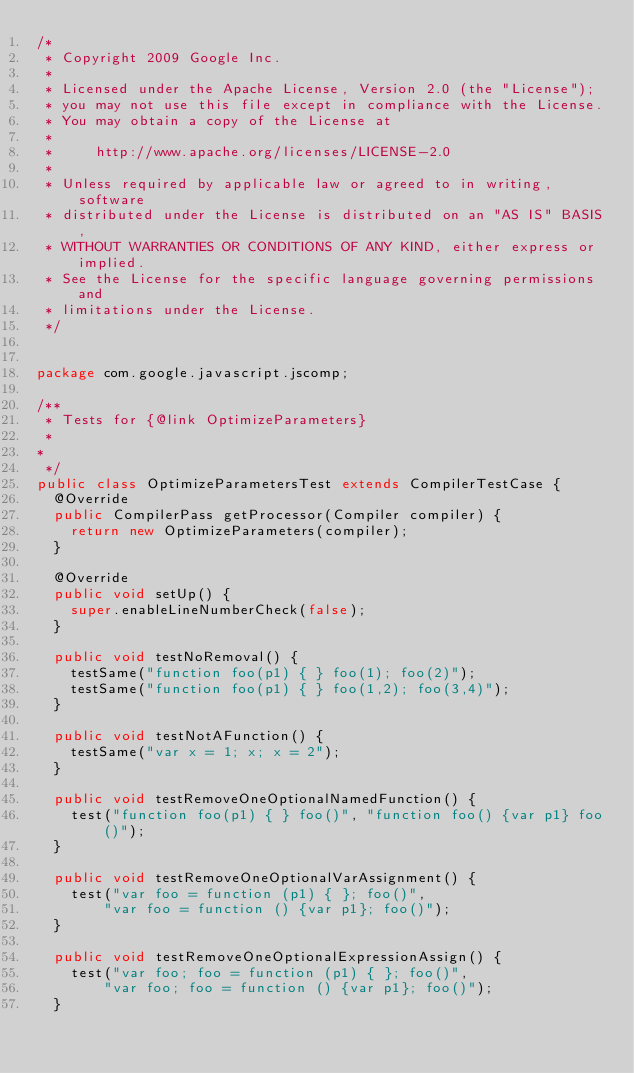Convert code to text. <code><loc_0><loc_0><loc_500><loc_500><_Java_>/*
 * Copyright 2009 Google Inc.
 *
 * Licensed under the Apache License, Version 2.0 (the "License");
 * you may not use this file except in compliance with the License.
 * You may obtain a copy of the License at
 *
 *     http://www.apache.org/licenses/LICENSE-2.0
 *
 * Unless required by applicable law or agreed to in writing, software
 * distributed under the License is distributed on an "AS IS" BASIS,
 * WITHOUT WARRANTIES OR CONDITIONS OF ANY KIND, either express or implied.
 * See the License for the specific language governing permissions and
 * limitations under the License.
 */


package com.google.javascript.jscomp;

/**
 * Tests for {@link OptimizeParameters}
 *
*
 */
public class OptimizeParametersTest extends CompilerTestCase {
  @Override
  public CompilerPass getProcessor(Compiler compiler) {
    return new OptimizeParameters(compiler);
  }

  @Override
  public void setUp() {
    super.enableLineNumberCheck(false);
  }

  public void testNoRemoval() {
    testSame("function foo(p1) { } foo(1); foo(2)");
    testSame("function foo(p1) { } foo(1,2); foo(3,4)");
  }

  public void testNotAFunction() {
    testSame("var x = 1; x; x = 2");
  }

  public void testRemoveOneOptionalNamedFunction() {
    test("function foo(p1) { } foo()", "function foo() {var p1} foo()");
  }

  public void testRemoveOneOptionalVarAssignment() {
    test("var foo = function (p1) { }; foo()",
        "var foo = function () {var p1}; foo()");
  }

  public void testRemoveOneOptionalExpressionAssign() {
    test("var foo; foo = function (p1) { }; foo()",
        "var foo; foo = function () {var p1}; foo()");
  }
</code> 